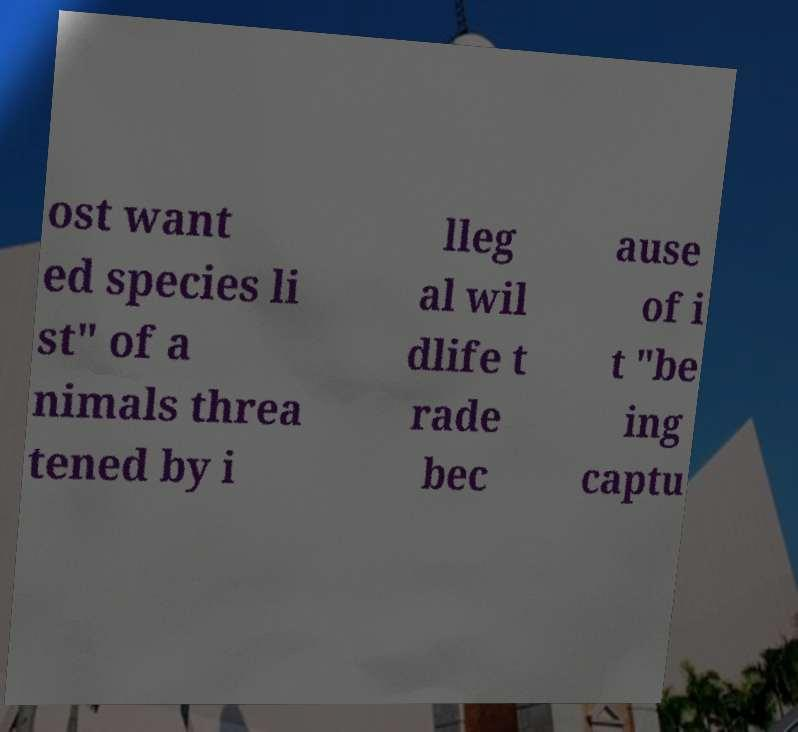Please read and relay the text visible in this image. What does it say? ost want ed species li st" of a nimals threa tened by i lleg al wil dlife t rade bec ause of i t "be ing captu 